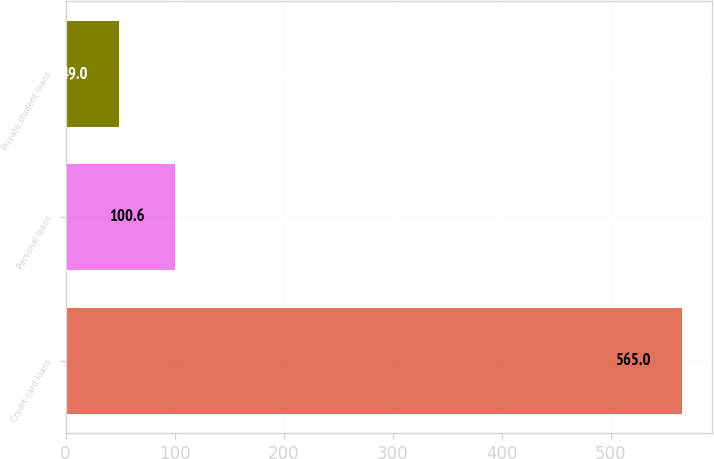Convert chart to OTSL. <chart><loc_0><loc_0><loc_500><loc_500><bar_chart><fcel>Credit card loans<fcel>Personal loans<fcel>Private student loans<nl><fcel>565<fcel>100.6<fcel>49<nl></chart> 